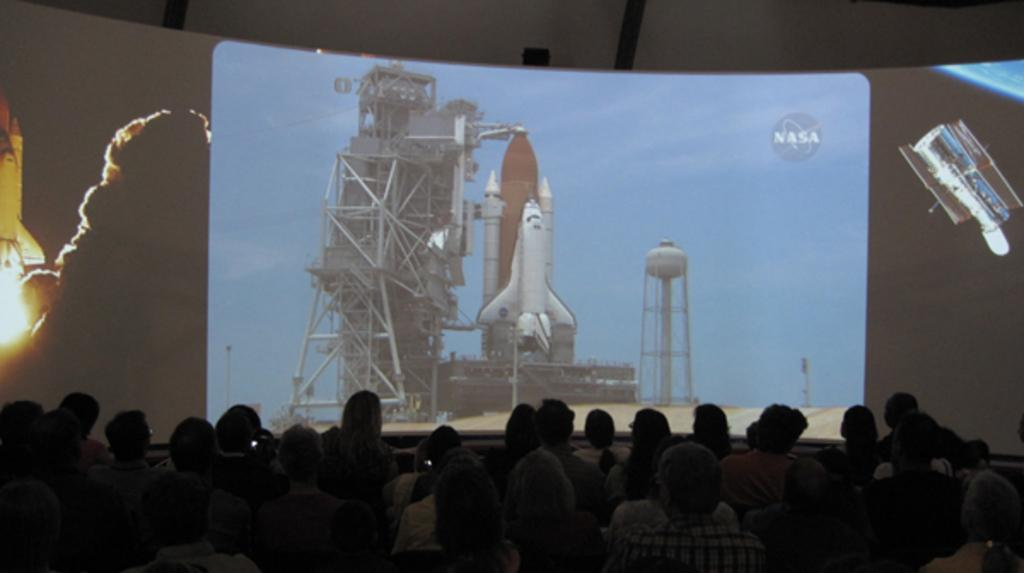What is happening in front of the screen in the image? There is a crowd in front of the screen. What is being displayed on the screen? A rocket is launching on the screen. What type of drain is visible in the image? There is no drain present in the image. Are there any worms crawling on the screen in the image? There are no worms visible in the image; the screen is displaying a rocket launch. 